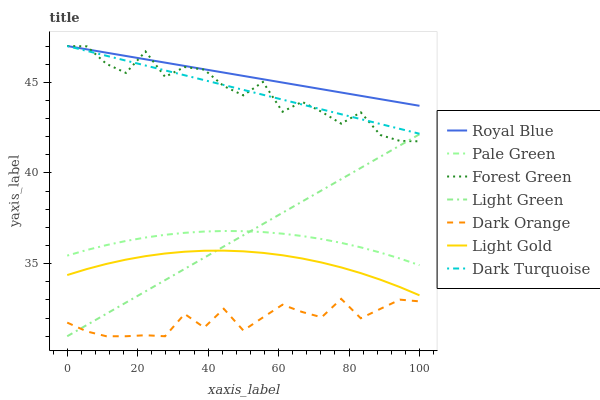Does Dark Orange have the minimum area under the curve?
Answer yes or no. Yes. Does Royal Blue have the maximum area under the curve?
Answer yes or no. Yes. Does Dark Turquoise have the minimum area under the curve?
Answer yes or no. No. Does Dark Turquoise have the maximum area under the curve?
Answer yes or no. No. Is Dark Turquoise the smoothest?
Answer yes or no. Yes. Is Forest Green the roughest?
Answer yes or no. Yes. Is Royal Blue the smoothest?
Answer yes or no. No. Is Royal Blue the roughest?
Answer yes or no. No. Does Dark Orange have the lowest value?
Answer yes or no. Yes. Does Dark Turquoise have the lowest value?
Answer yes or no. No. Does Forest Green have the highest value?
Answer yes or no. Yes. Does Pale Green have the highest value?
Answer yes or no. No. Is Light Green less than Royal Blue?
Answer yes or no. Yes. Is Forest Green greater than Light Gold?
Answer yes or no. Yes. Does Dark Turquoise intersect Royal Blue?
Answer yes or no. Yes. Is Dark Turquoise less than Royal Blue?
Answer yes or no. No. Is Dark Turquoise greater than Royal Blue?
Answer yes or no. No. Does Light Green intersect Royal Blue?
Answer yes or no. No. 